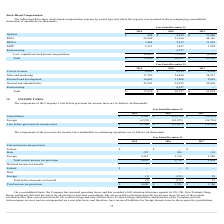According to Cornerstone Ondemand's financial document, Why has the company incurred liabilities for foreign income taxes? Certain foreign subsidiaries and branches of the Company provide intercompany services and are compensated on a cost-plus basis. The document states: "efit) for certain foreign and state income taxes. Certain foreign subsidiaries and branches of the Company provide intercompany services and are compe..." Also, What is the provision for State income tax in 2018? According to the financial document, 204 (in thousands). The relevant text states: "State 225 204 114..." Also, What is the provision for Foreign income tax in 2019? According to the financial document, 2,467 (in thousands). The relevant text states: "Foreign 2,467 2,514 1,580..." Also, can you calculate: What percentage of total current income tax provision consist of State income tax provisions in 2019? Based on the calculation: (225/2,692), the result is 8.36 (percentage). This is based on the information: "State 225 204 114 Total current income tax provision 2,692 2,718 1,694..." The key data points involved are: 2,692, 225. Also, can you calculate: What is the percentage change in state income tax provision between 2017 and 2018? To answer this question, I need to perform calculations using the financial data. The calculation is: (204-114)/114, which equals 78.95 (percentage). This is based on the information: "State 225 204 114 State 225 204 114..." The key data points involved are: 114, 204. Also, can you calculate: What is the change in foreign income tax provision between 2018 and 2019? Based on the calculation: (2,467-2,514), the result is -47 (in thousands). This is based on the information: "Foreign 2,467 2,514 1,580 Foreign 2,467 2,514 1,580..." The key data points involved are: 2,467, 2,514. 